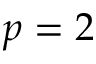Convert formula to latex. <formula><loc_0><loc_0><loc_500><loc_500>p = 2</formula> 